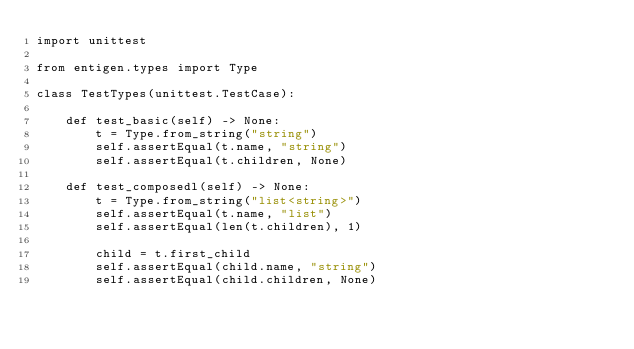<code> <loc_0><loc_0><loc_500><loc_500><_Python_>import unittest

from entigen.types import Type

class TestTypes(unittest.TestCase):

    def test_basic(self) -> None:
        t = Type.from_string("string")
        self.assertEqual(t.name, "string")
        self.assertEqual(t.children, None)

    def test_composedl(self) -> None:
        t = Type.from_string("list<string>")
        self.assertEqual(t.name, "list")
        self.assertEqual(len(t.children), 1)

        child = t.first_child
        self.assertEqual(child.name, "string")
        self.assertEqual(child.children, None)
</code> 